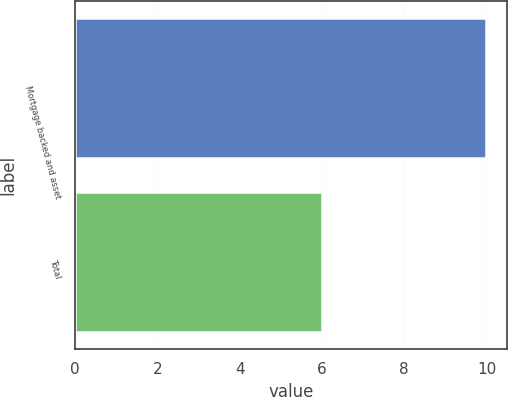Convert chart. <chart><loc_0><loc_0><loc_500><loc_500><bar_chart><fcel>Mortgage backed and asset<fcel>Total<nl><fcel>10<fcel>6<nl></chart> 